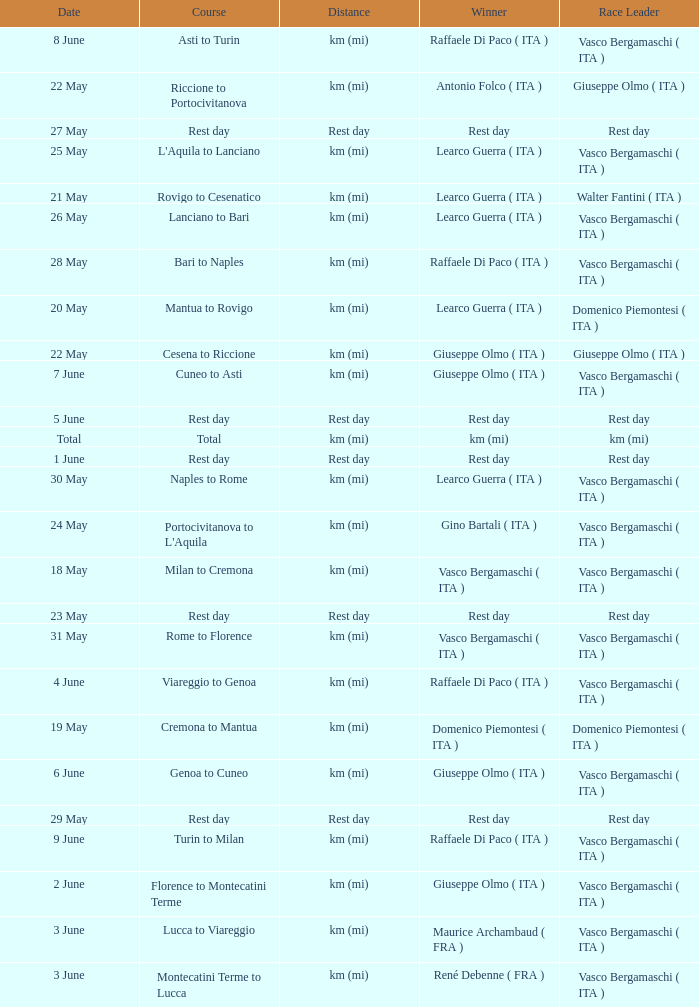Who won on 28 May? Raffaele Di Paco ( ITA ). 